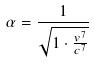<formula> <loc_0><loc_0><loc_500><loc_500>\alpha = \frac { 1 } { \sqrt { 1 \cdot \frac { v ^ { 7 } } { c ^ { 7 } } } }</formula> 